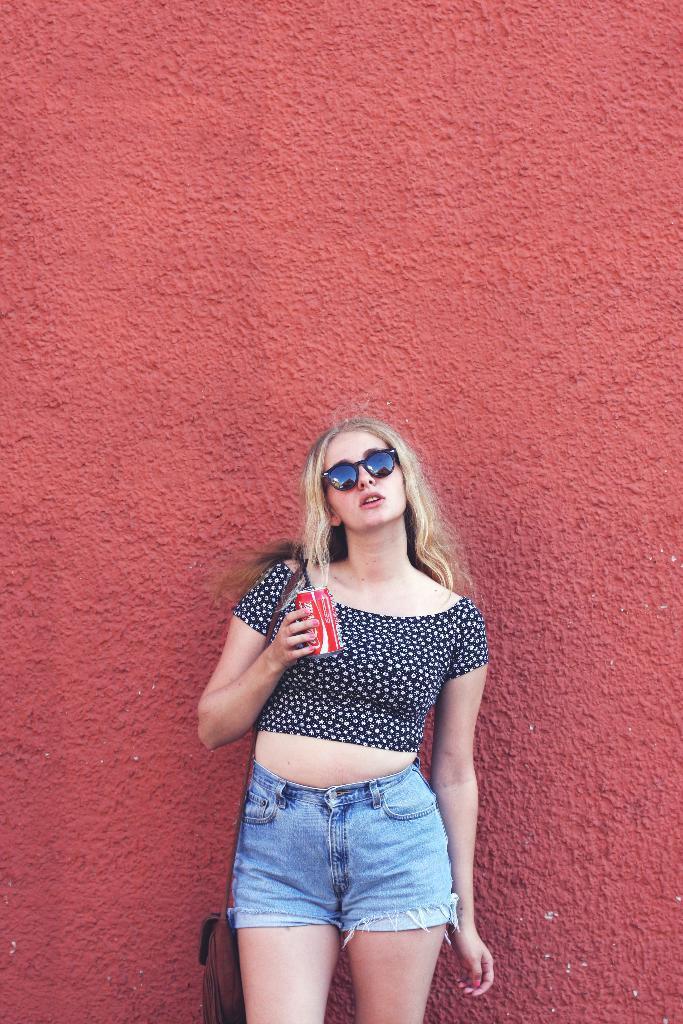Describe this image in one or two sentences. In this image I can see a person is holding red color object and wearing blue top and jeans short. Background is in red color. 